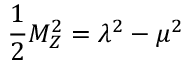<formula> <loc_0><loc_0><loc_500><loc_500>\frac { 1 } { 2 } M _ { Z } ^ { 2 } = \lambda ^ { 2 } - \mu ^ { 2 }</formula> 